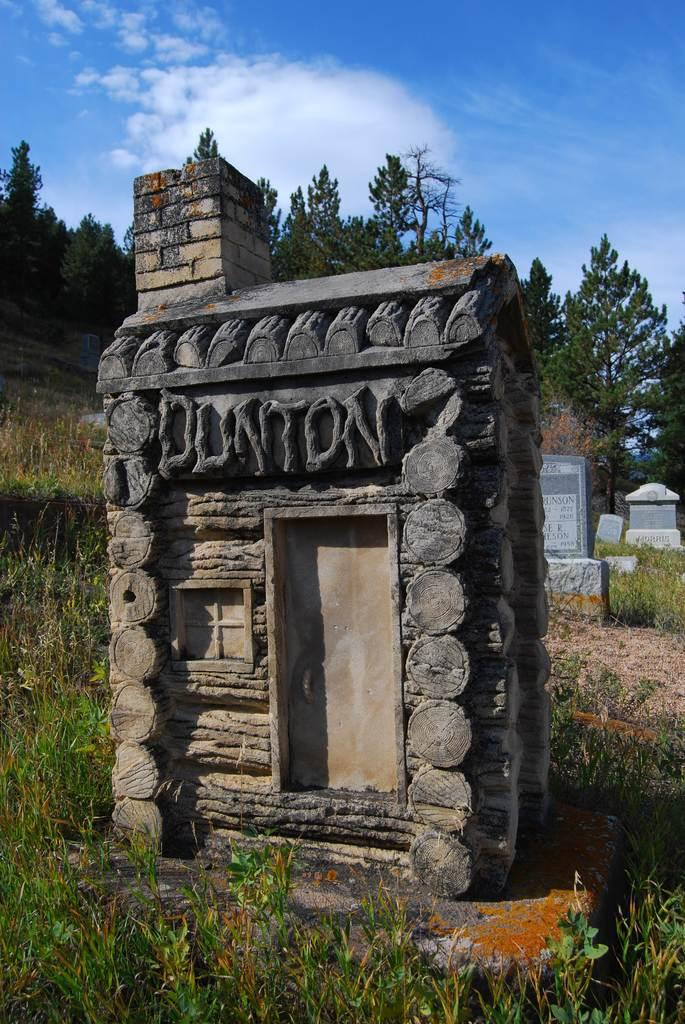<image>
Create a compact narrative representing the image presented. A small house looking structure built outside that says Dunton. 